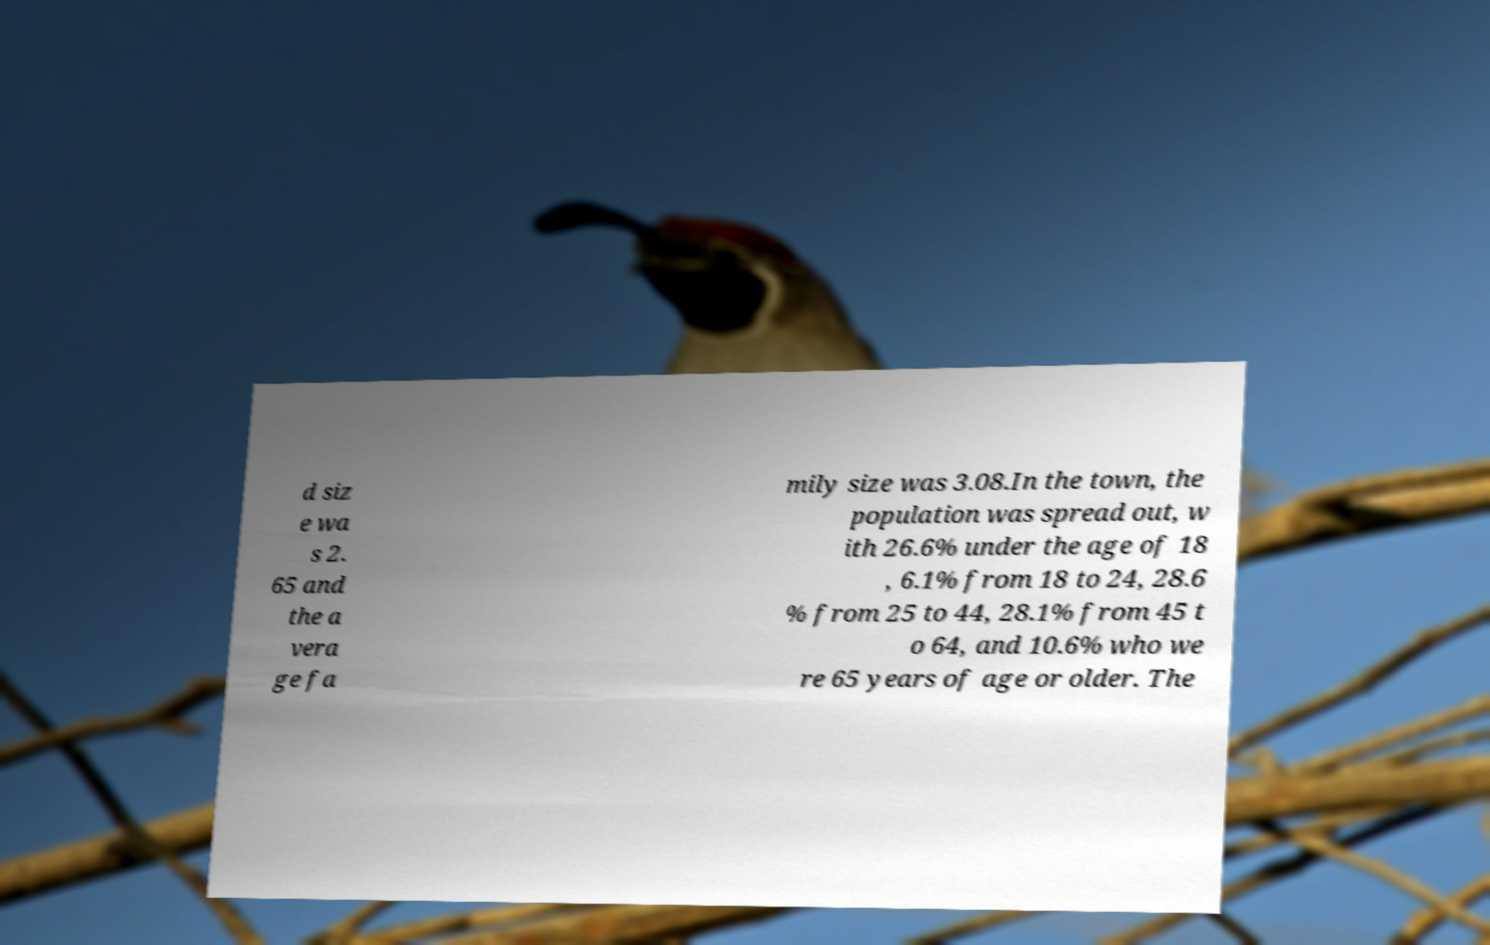Could you extract and type out the text from this image? d siz e wa s 2. 65 and the a vera ge fa mily size was 3.08.In the town, the population was spread out, w ith 26.6% under the age of 18 , 6.1% from 18 to 24, 28.6 % from 25 to 44, 28.1% from 45 t o 64, and 10.6% who we re 65 years of age or older. The 